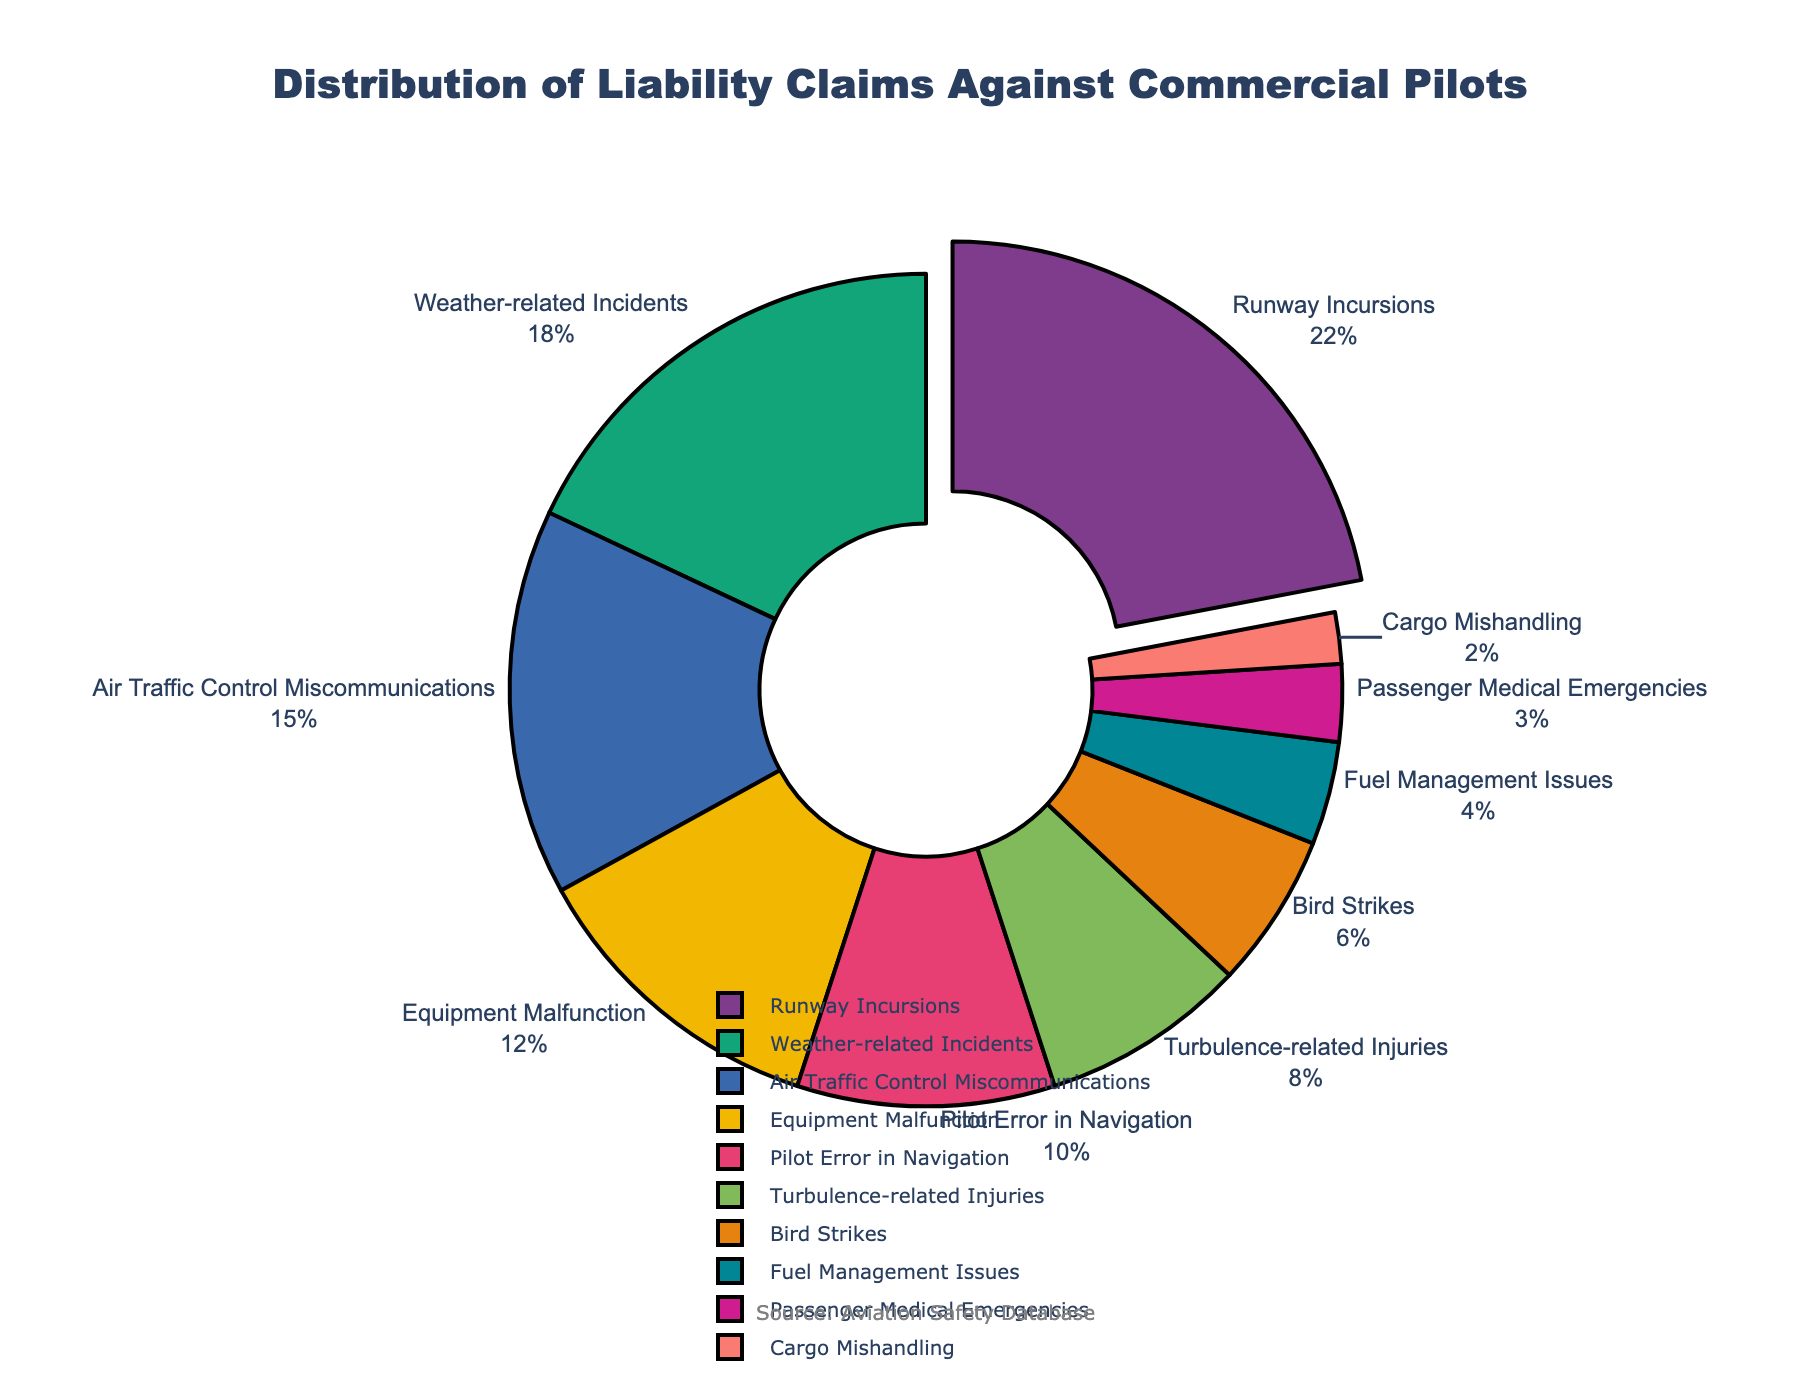What percentage of liability claims are due to runway incursions? The visual representation shows each segment labeled with its percentage. Find the segment labeled "Runway Incursions" and read the percentage value.
Answer: 22% How many types of incidents account for more than 15% of liability claims? Identify the segments in the pie chart with percentages greater than 15%. Count these segments.
Answer: 3 What is the combined percentage of claims due to pilot error in navigation and fuel management issues? Locate the segments labeled "Pilot Error in Navigation" and "Fuel Management Issues". Add their percentage values. 10% + 4% = 14%
Answer: 14% Which incident type accounts for the smallest percentage of liability claims? Find the segment with the smallest percentage value. The segment labeled "Cargo Mishandling" has the smallest value.
Answer: Cargo Mishandling How much larger is the percentage of weather-related incidents compared to turbulence-related injuries? Locate the segments labeled "Weather-related Incidents" and "Turbulence-related Injuries". Subtract the percentage of turbulence-related injuries from weather-related incidents. 18% - 8% = 10%
Answer: 10% What are the colors of the segments for runway incursions and bird strikes? The visual representation uses different colors for each segment. The "Runway Incursions" segment is typically pulled out and colored distinctly, and the "Bird Strikes" segment has another unique color. Observe the colors visually.
Answer: Varies based on the color palette used, typically bold, distinct colors Which incident types have a percentage between 5% and 10%? Identify the segments whose percentage values are between 5% and 10%. These are "Turbulence-related Injuries" and "Bird Strikes".
Answer: Turbulence-related Injuries, Bird Strikes If you sum up the percentages of runway incursions, air traffic control miscommunications, and equipment malfunction, what is the total? Locate the segments for "Runway Incursions", "Air Traffic Control Miscommunications", and "Equipment Malfunction". Add their percentage values. 22% + 15% + 12% = 49%
Answer: 49% Which incident type has a 12% share, and what is its color? Locate the segment with a 12% share. This is labeled "Equipment Malfunction". Check its color visually.
Answer: Equipment Malfunction, varies based on the color palette used What incident types constitute less than 5% of liability claims? Identify the segments with percentages less than 5%. These are "Fuel Management Issues", "Passenger Medical Emergencies", and "Cargo Mishandling".
Answer: Fuel Management Issues, Passenger Medical Emergencies, Cargo Mishandling 